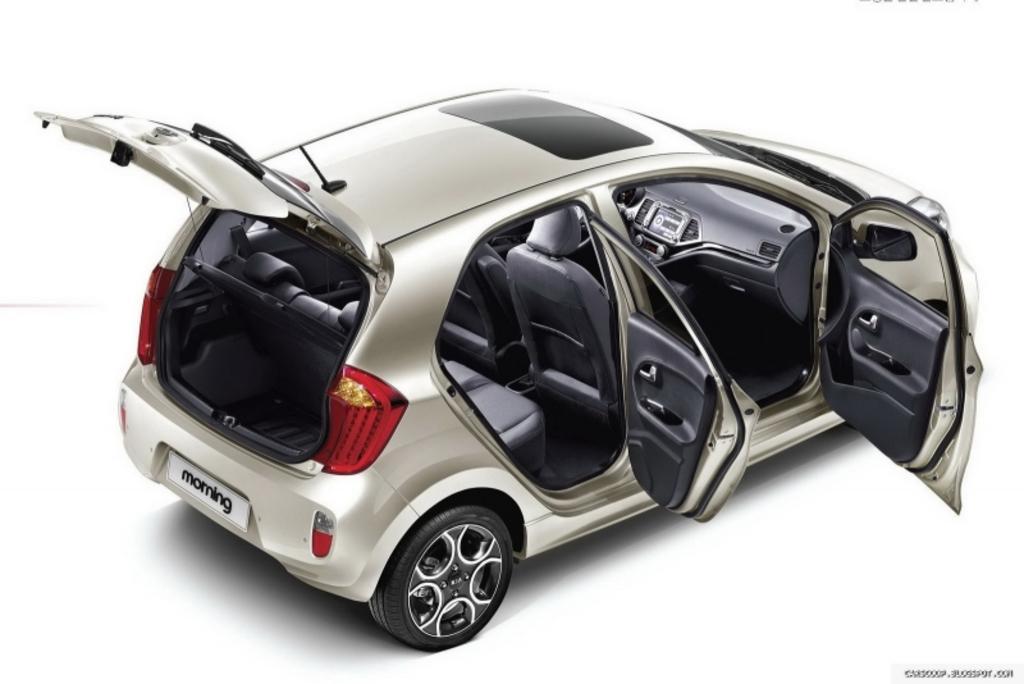Describe this image in one or two sentences. This is a 5 seater car. All its doors are open. At the back there is a white registration plate on which ''morning'' is written. There is a white background. 